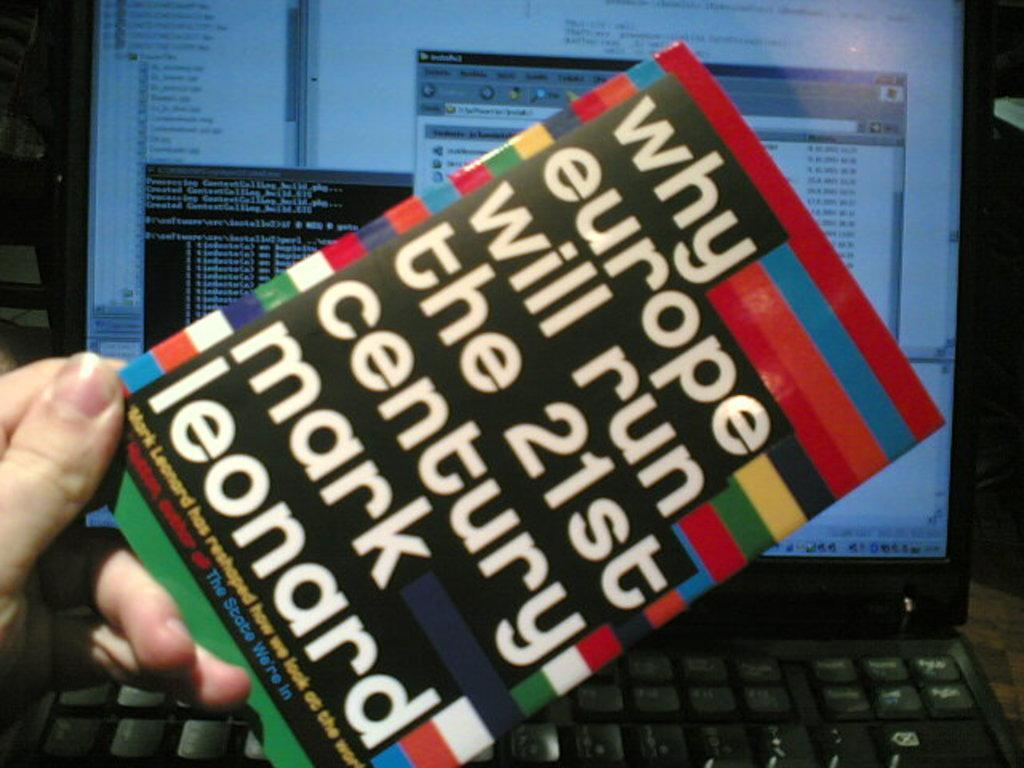Provide a one-sentence caption for the provided image. Mark Leonard's book is about why Europe will run this century. 